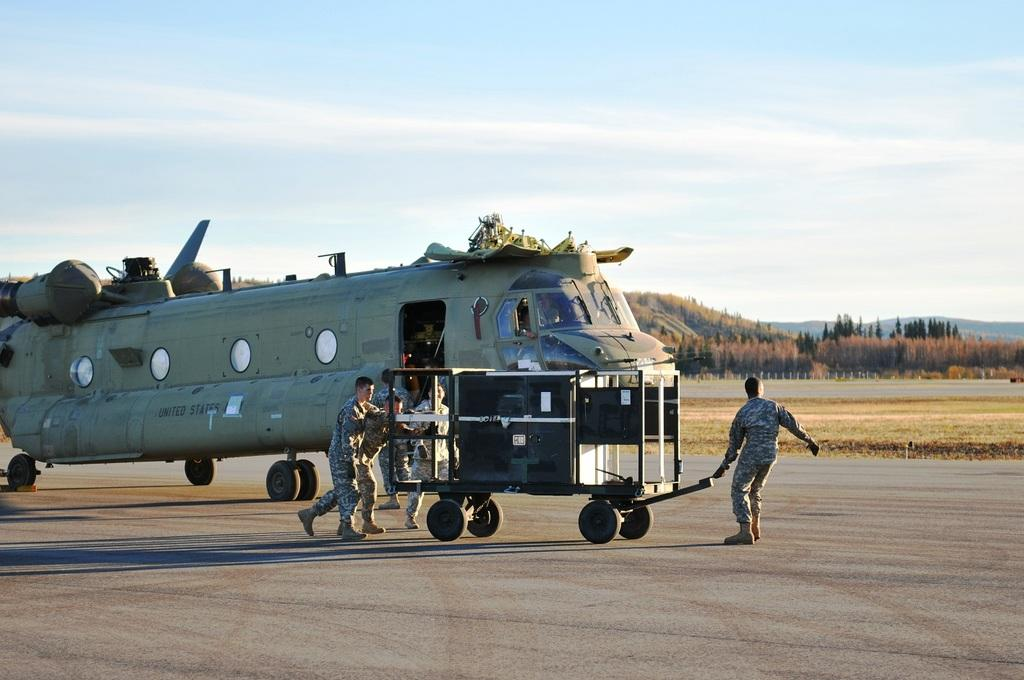What is the main subject of the image? The main subject of the image is an airplane on the ground. Are there any people in the image? Yes, there are people in the image. What type of natural environment is visible in the image? There are trees and grass visible in the image. What can be seen in the background of the image? In the background of the image, there are mountains and the sky with clouds. What type of news can be heard coming from the airplane in the image? There is no indication in the image that the airplane is broadcasting any news, so it's not possible to determine what, if any, news might be heard. 